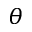Convert formula to latex. <formula><loc_0><loc_0><loc_500><loc_500>\theta</formula> 